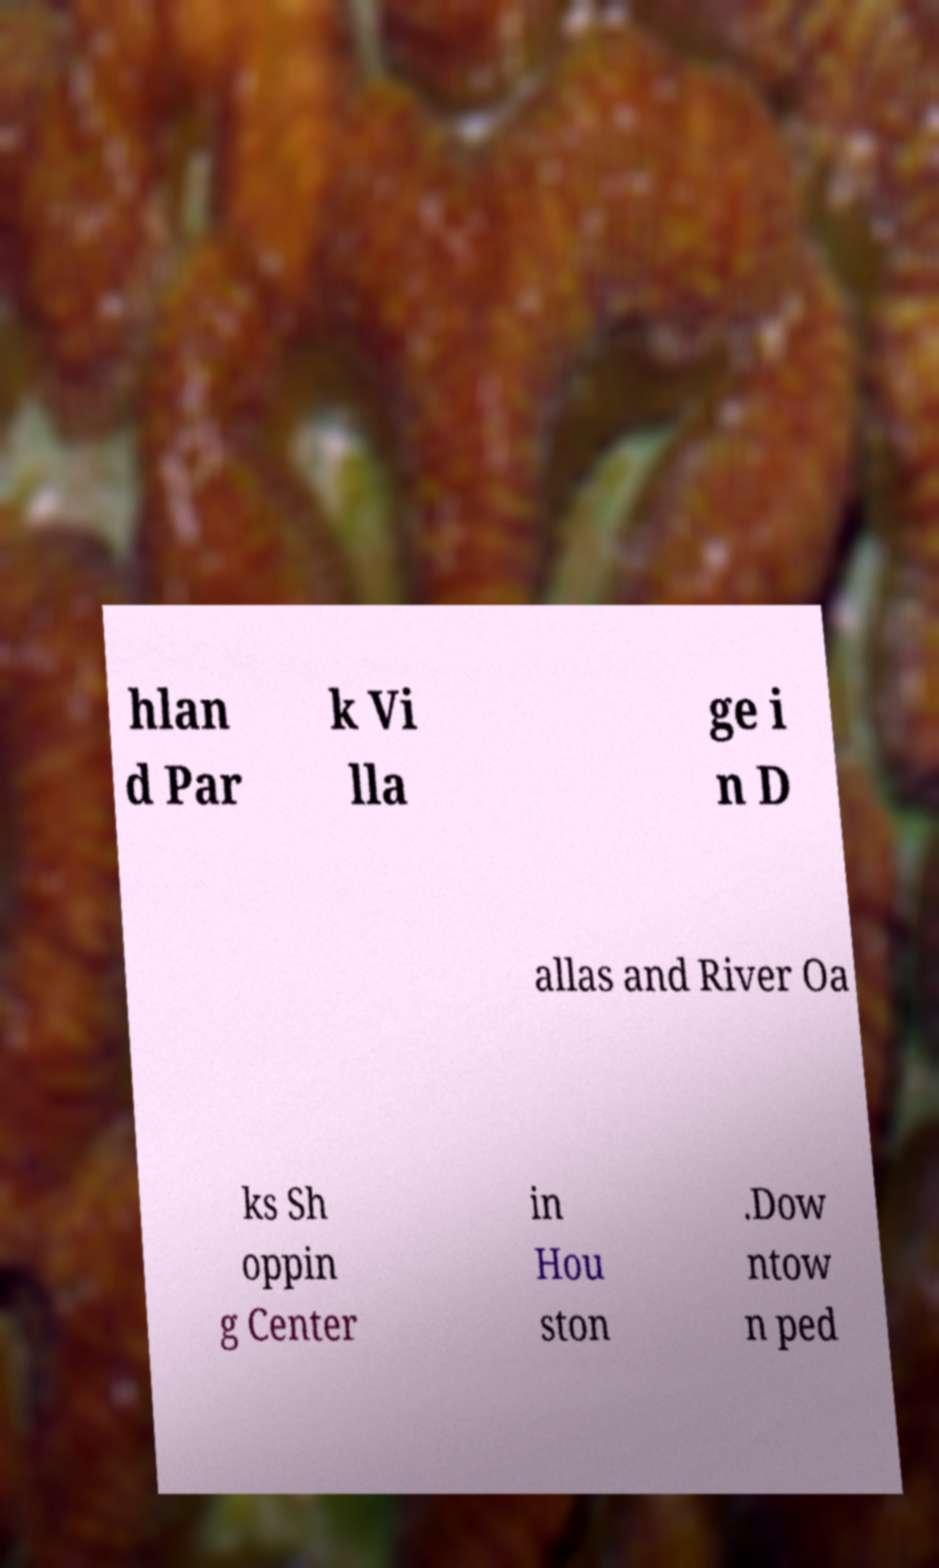Please read and relay the text visible in this image. What does it say? hlan d Par k Vi lla ge i n D allas and River Oa ks Sh oppin g Center in Hou ston .Dow ntow n ped 